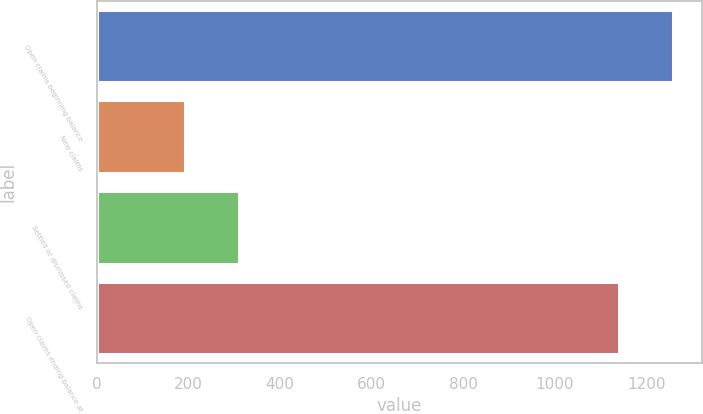Convert chart. <chart><loc_0><loc_0><loc_500><loc_500><bar_chart><fcel>Open claims beginning balance<fcel>New claims<fcel>Settled or dismissed claims<fcel>Open claims ending balance at<nl><fcel>1258<fcel>192<fcel>310<fcel>1140<nl></chart> 